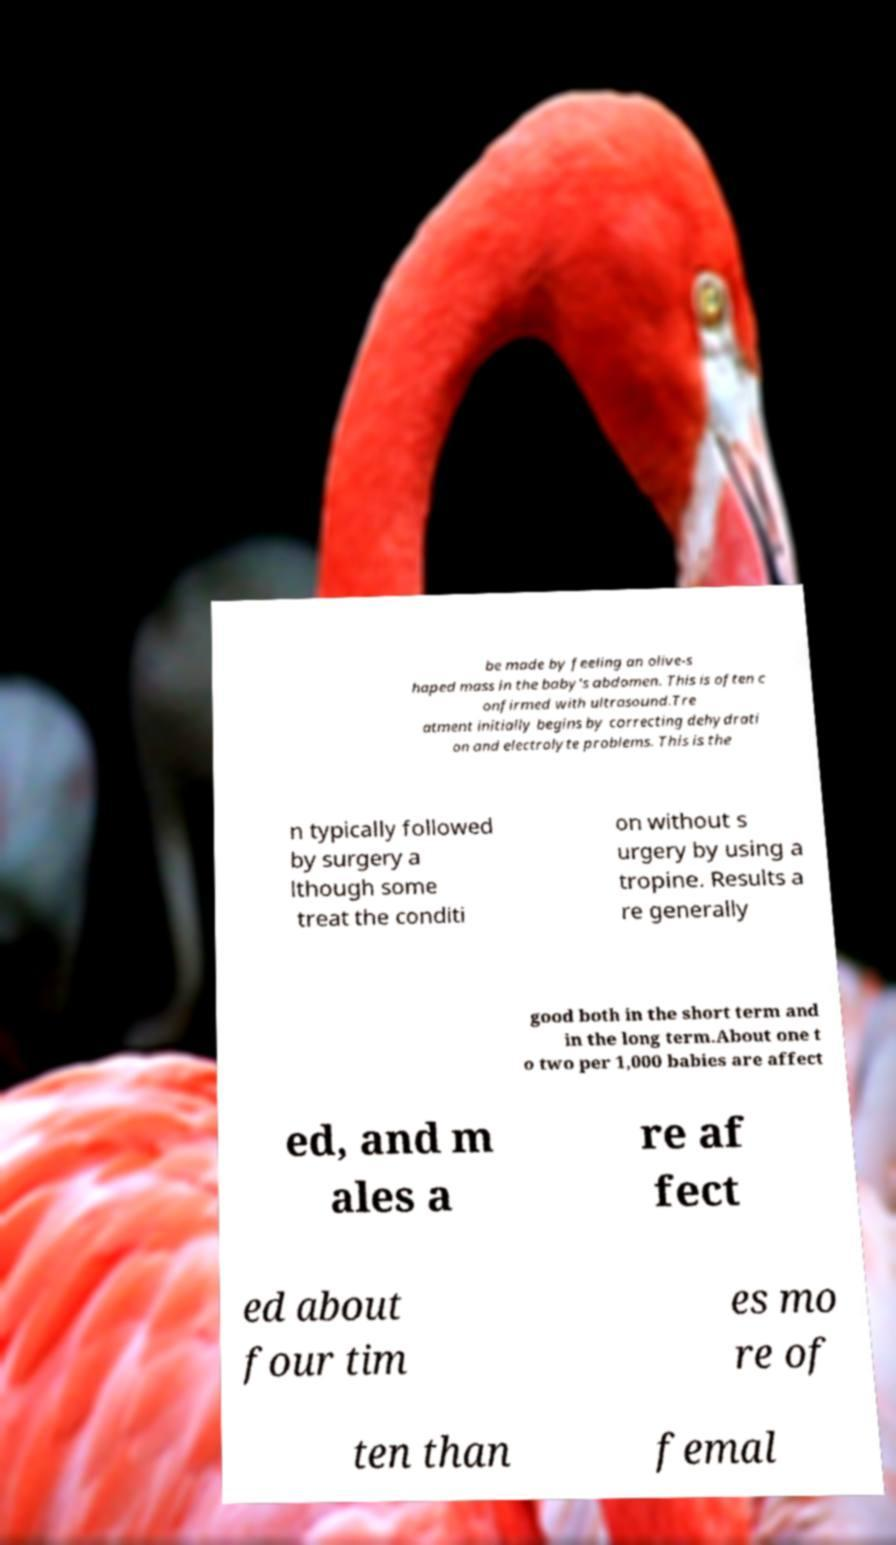Can you accurately transcribe the text from the provided image for me? be made by feeling an olive-s haped mass in the baby's abdomen. This is often c onfirmed with ultrasound.Tre atment initially begins by correcting dehydrati on and electrolyte problems. This is the n typically followed by surgery a lthough some treat the conditi on without s urgery by using a tropine. Results a re generally good both in the short term and in the long term.About one t o two per 1,000 babies are affect ed, and m ales a re af fect ed about four tim es mo re of ten than femal 